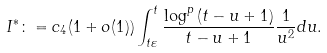Convert formula to latex. <formula><loc_0><loc_0><loc_500><loc_500>I ^ { \ast } \colon = c _ { 4 } ( 1 + o ( 1 ) ) \int _ { t \varepsilon } ^ { t } \frac { \log ^ { p } \left ( t - u + 1 \right ) } { t - u + 1 } \frac { 1 } { u ^ { 2 } } d u .</formula> 